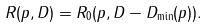Convert formula to latex. <formula><loc_0><loc_0><loc_500><loc_500>R ( p , D ) = R _ { 0 } ( p , D - D _ { \min } ( p ) ) .</formula> 